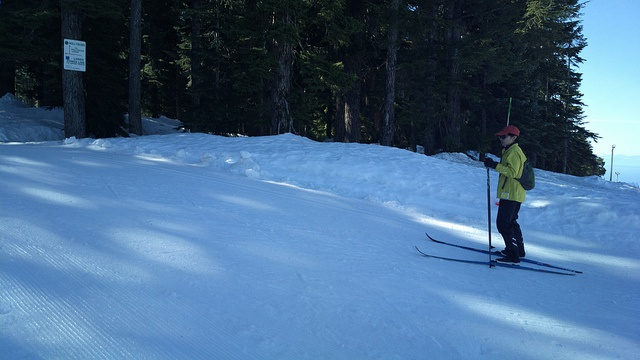Describe the objects in this image and their specific colors. I can see people in navy, black, darkgreen, and olive tones, backpack in navy, black, gray, and blue tones, and skis in navy, blue, gray, and black tones in this image. 